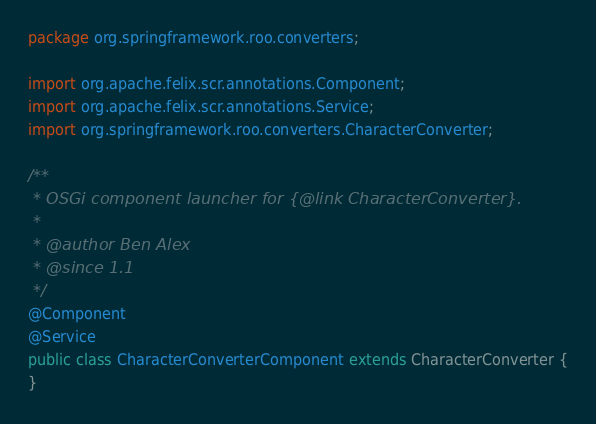<code> <loc_0><loc_0><loc_500><loc_500><_Java_>package org.springframework.roo.converters;

import org.apache.felix.scr.annotations.Component;
import org.apache.felix.scr.annotations.Service;
import org.springframework.roo.converters.CharacterConverter;

/**
 * OSGi component launcher for {@link CharacterConverter}.
 * 
 * @author Ben Alex
 * @since 1.1
 */
@Component
@Service
public class CharacterConverterComponent extends CharacterConverter {
}
</code> 